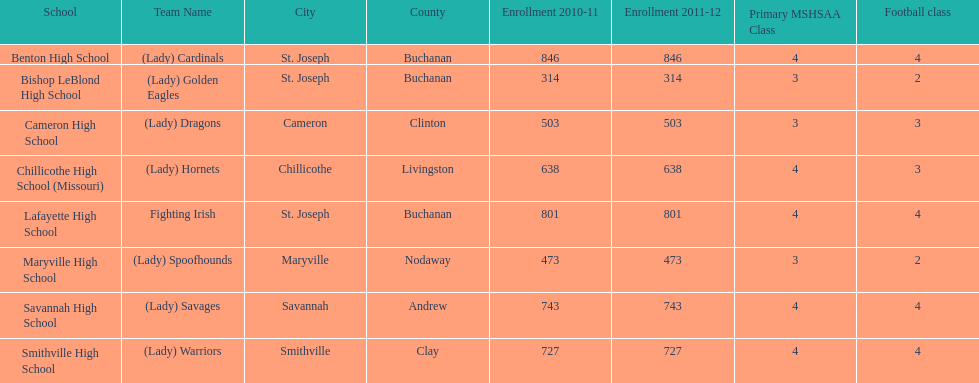How many of the schools had at least 500 students enrolled in the 2010-2011 and 2011-2012 season? 6. 